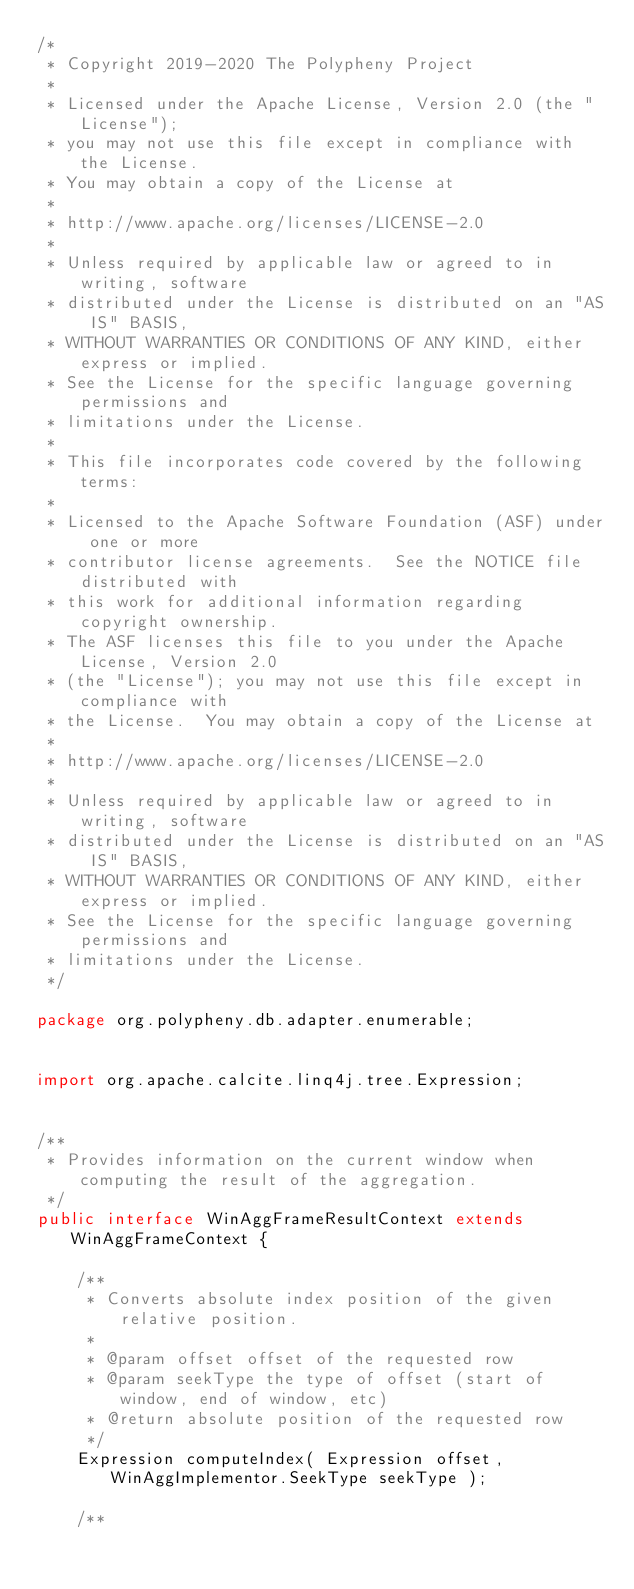Convert code to text. <code><loc_0><loc_0><loc_500><loc_500><_Java_>/*
 * Copyright 2019-2020 The Polypheny Project
 *
 * Licensed under the Apache License, Version 2.0 (the "License");
 * you may not use this file except in compliance with the License.
 * You may obtain a copy of the License at
 *
 * http://www.apache.org/licenses/LICENSE-2.0
 *
 * Unless required by applicable law or agreed to in writing, software
 * distributed under the License is distributed on an "AS IS" BASIS,
 * WITHOUT WARRANTIES OR CONDITIONS OF ANY KIND, either express or implied.
 * See the License for the specific language governing permissions and
 * limitations under the License.
 *
 * This file incorporates code covered by the following terms:
 *
 * Licensed to the Apache Software Foundation (ASF) under one or more
 * contributor license agreements.  See the NOTICE file distributed with
 * this work for additional information regarding copyright ownership.
 * The ASF licenses this file to you under the Apache License, Version 2.0
 * (the "License"); you may not use this file except in compliance with
 * the License.  You may obtain a copy of the License at
 *
 * http://www.apache.org/licenses/LICENSE-2.0
 *
 * Unless required by applicable law or agreed to in writing, software
 * distributed under the License is distributed on an "AS IS" BASIS,
 * WITHOUT WARRANTIES OR CONDITIONS OF ANY KIND, either express or implied.
 * See the License for the specific language governing permissions and
 * limitations under the License.
 */

package org.polypheny.db.adapter.enumerable;


import org.apache.calcite.linq4j.tree.Expression;


/**
 * Provides information on the current window when computing the result of the aggregation.
 */
public interface WinAggFrameResultContext extends WinAggFrameContext {

    /**
     * Converts absolute index position of the given relative position.
     *
     * @param offset offset of the requested row
     * @param seekType the type of offset (start of window, end of window, etc)
     * @return absolute position of the requested row
     */
    Expression computeIndex( Expression offset, WinAggImplementor.SeekType seekType );

    /**</code> 